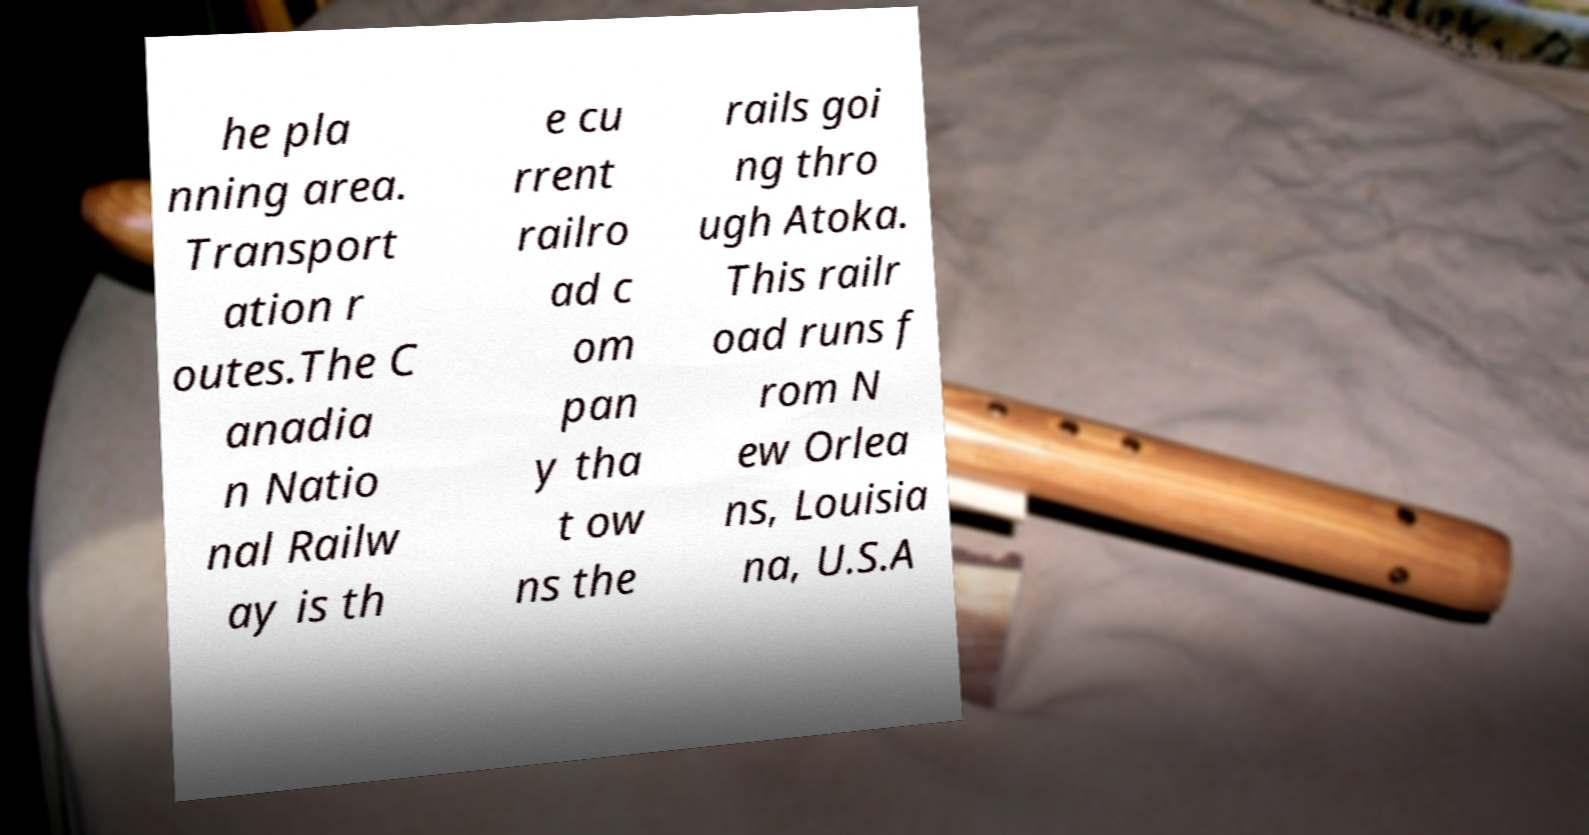Could you extract and type out the text from this image? he pla nning area. Transport ation r outes.The C anadia n Natio nal Railw ay is th e cu rrent railro ad c om pan y tha t ow ns the rails goi ng thro ugh Atoka. This railr oad runs f rom N ew Orlea ns, Louisia na, U.S.A 